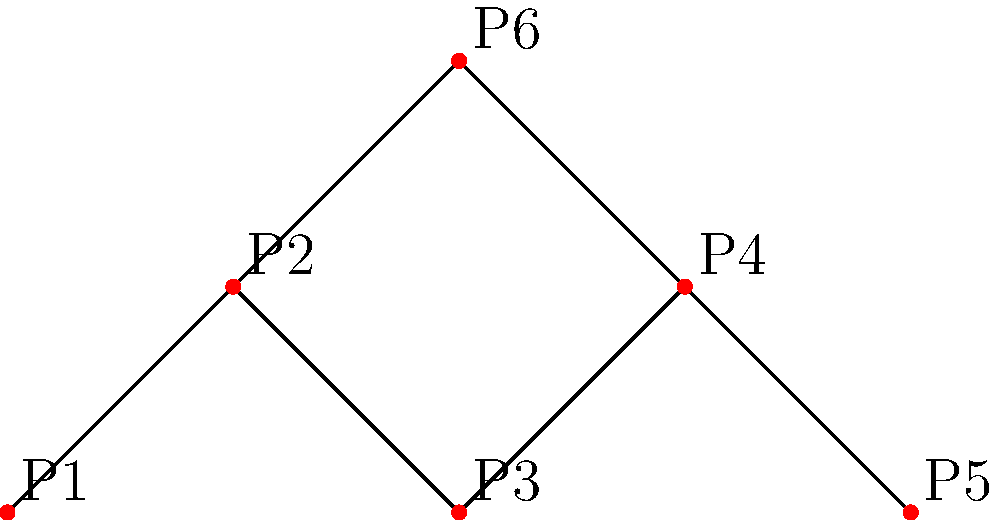The diagram represents the connectivity of Fujieda MYFC's player positions on the field. Each node (P1 to P6) represents a player, and the edges represent possible direct passes between players. What is the minimum number of players that need to be removed to disconnect P1 from P4? To solve this problem, we need to analyze the possible paths from P1 to P4:

1. First path: P1 → P2 → P3 → P4
2. Second path: P1 → P2 → P6 → P4

To disconnect P1 from P4, we need to break both of these paths.

Step 1: Identify the common node in both paths.
- P2 is present in both paths.

Step 2: Determine if removing P2 is sufficient.
- If we remove P2, both paths are broken, and P1 can no longer reach P4.

Step 3: Check if there's a solution with fewer removals.
- There is no single player that, when removed, would break both paths simultaneously.
- Removing any other single player would leave at least one path intact.

Therefore, the minimum number of players that need to be removed to disconnect P1 from P4 is 1, which is achieved by removing P2.
Answer: 1 